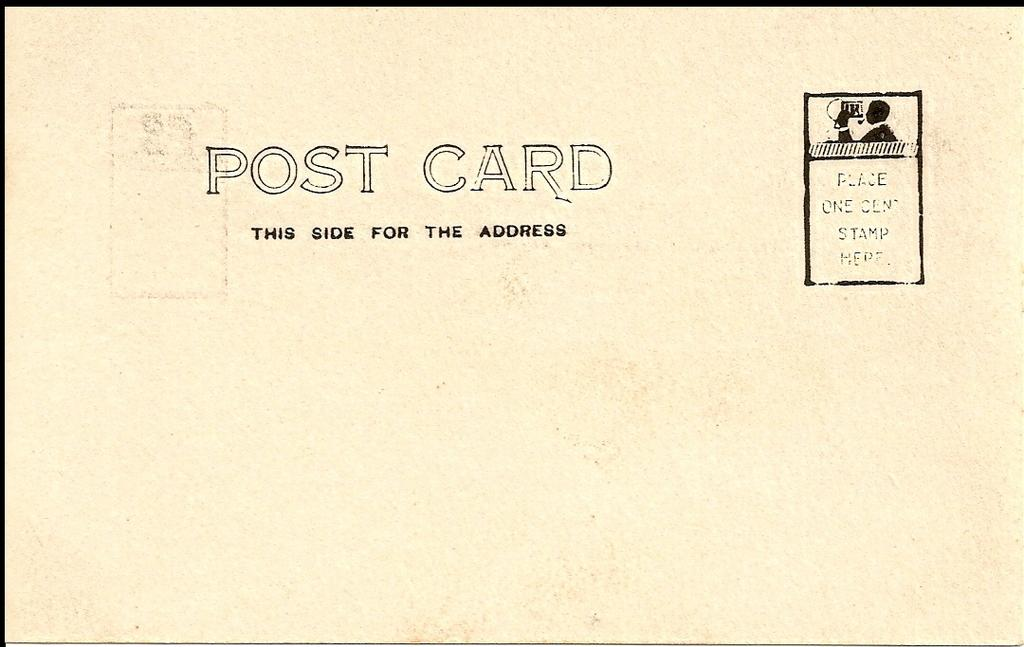<image>
Summarize the visual content of the image. Post card with this side for the address on the front 